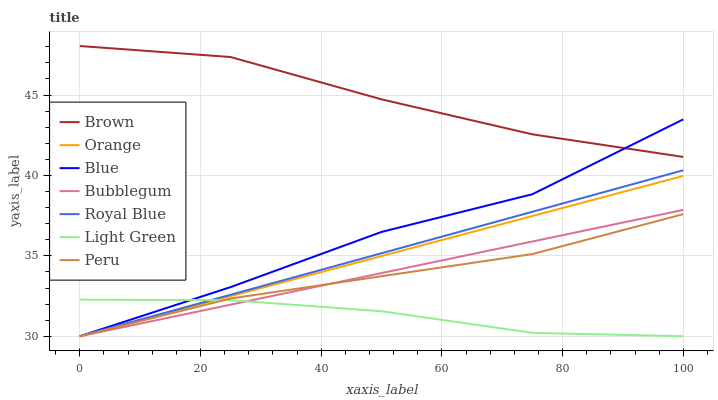Does Peru have the minimum area under the curve?
Answer yes or no. No. Does Peru have the maximum area under the curve?
Answer yes or no. No. Is Brown the smoothest?
Answer yes or no. No. Is Brown the roughest?
Answer yes or no. No. Does Brown have the lowest value?
Answer yes or no. No. Does Peru have the highest value?
Answer yes or no. No. Is Light Green less than Brown?
Answer yes or no. Yes. Is Brown greater than Orange?
Answer yes or no. Yes. Does Light Green intersect Brown?
Answer yes or no. No. 